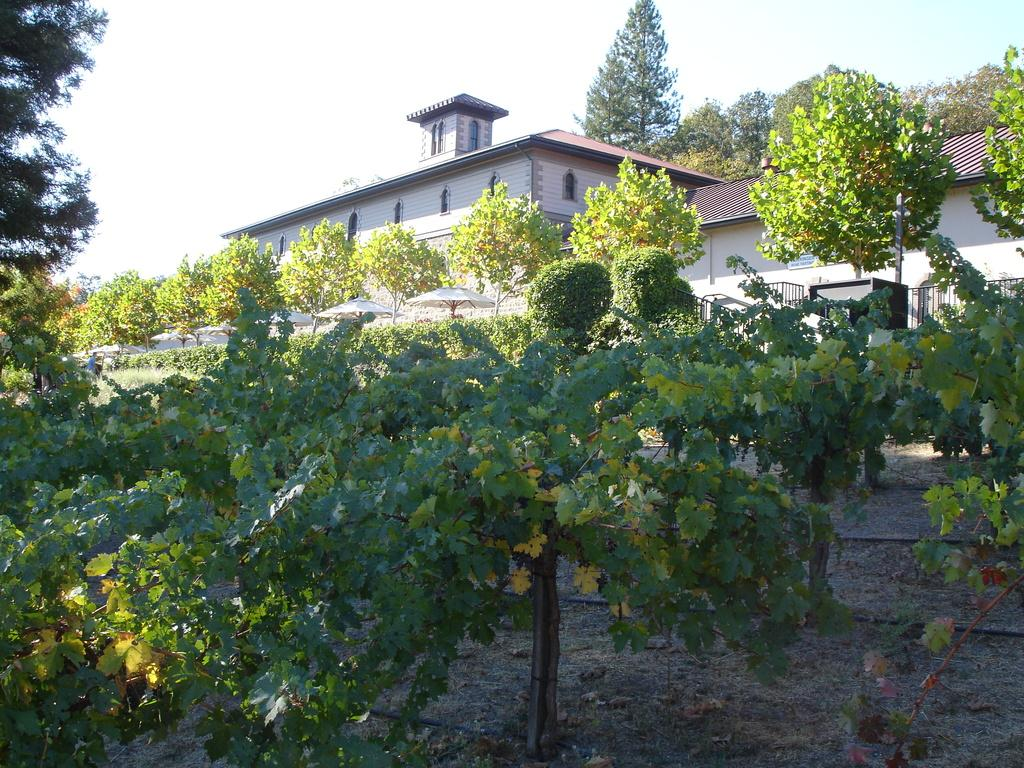What type of vegetation can be seen in the image? There are plants and trees in the image. What objects are present in the image for protection from the sun or rain? There are umbrellas in the image. What architectural feature can be seen in the image? There are iron grilles in the image. What vertical structure is present in the image? There is a pole in the image. What type of barrier can be seen in the image? There is a wall in the image. What type of buildings are visible in the image? There are houses in the image. What part of the natural environment is visible in the image? The sky is visible in the image. What type of plastic material is used to make the pan in the image? There is no pan present in the image. How many houses are visible on the left side of the image? The provided facts do not specify the number of houses or their location in the image. 